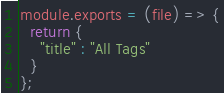<code> <loc_0><loc_0><loc_500><loc_500><_JavaScript_>module.exports = (file) => {
  return {
    "title" : "All Tags"
  }
};
</code> 